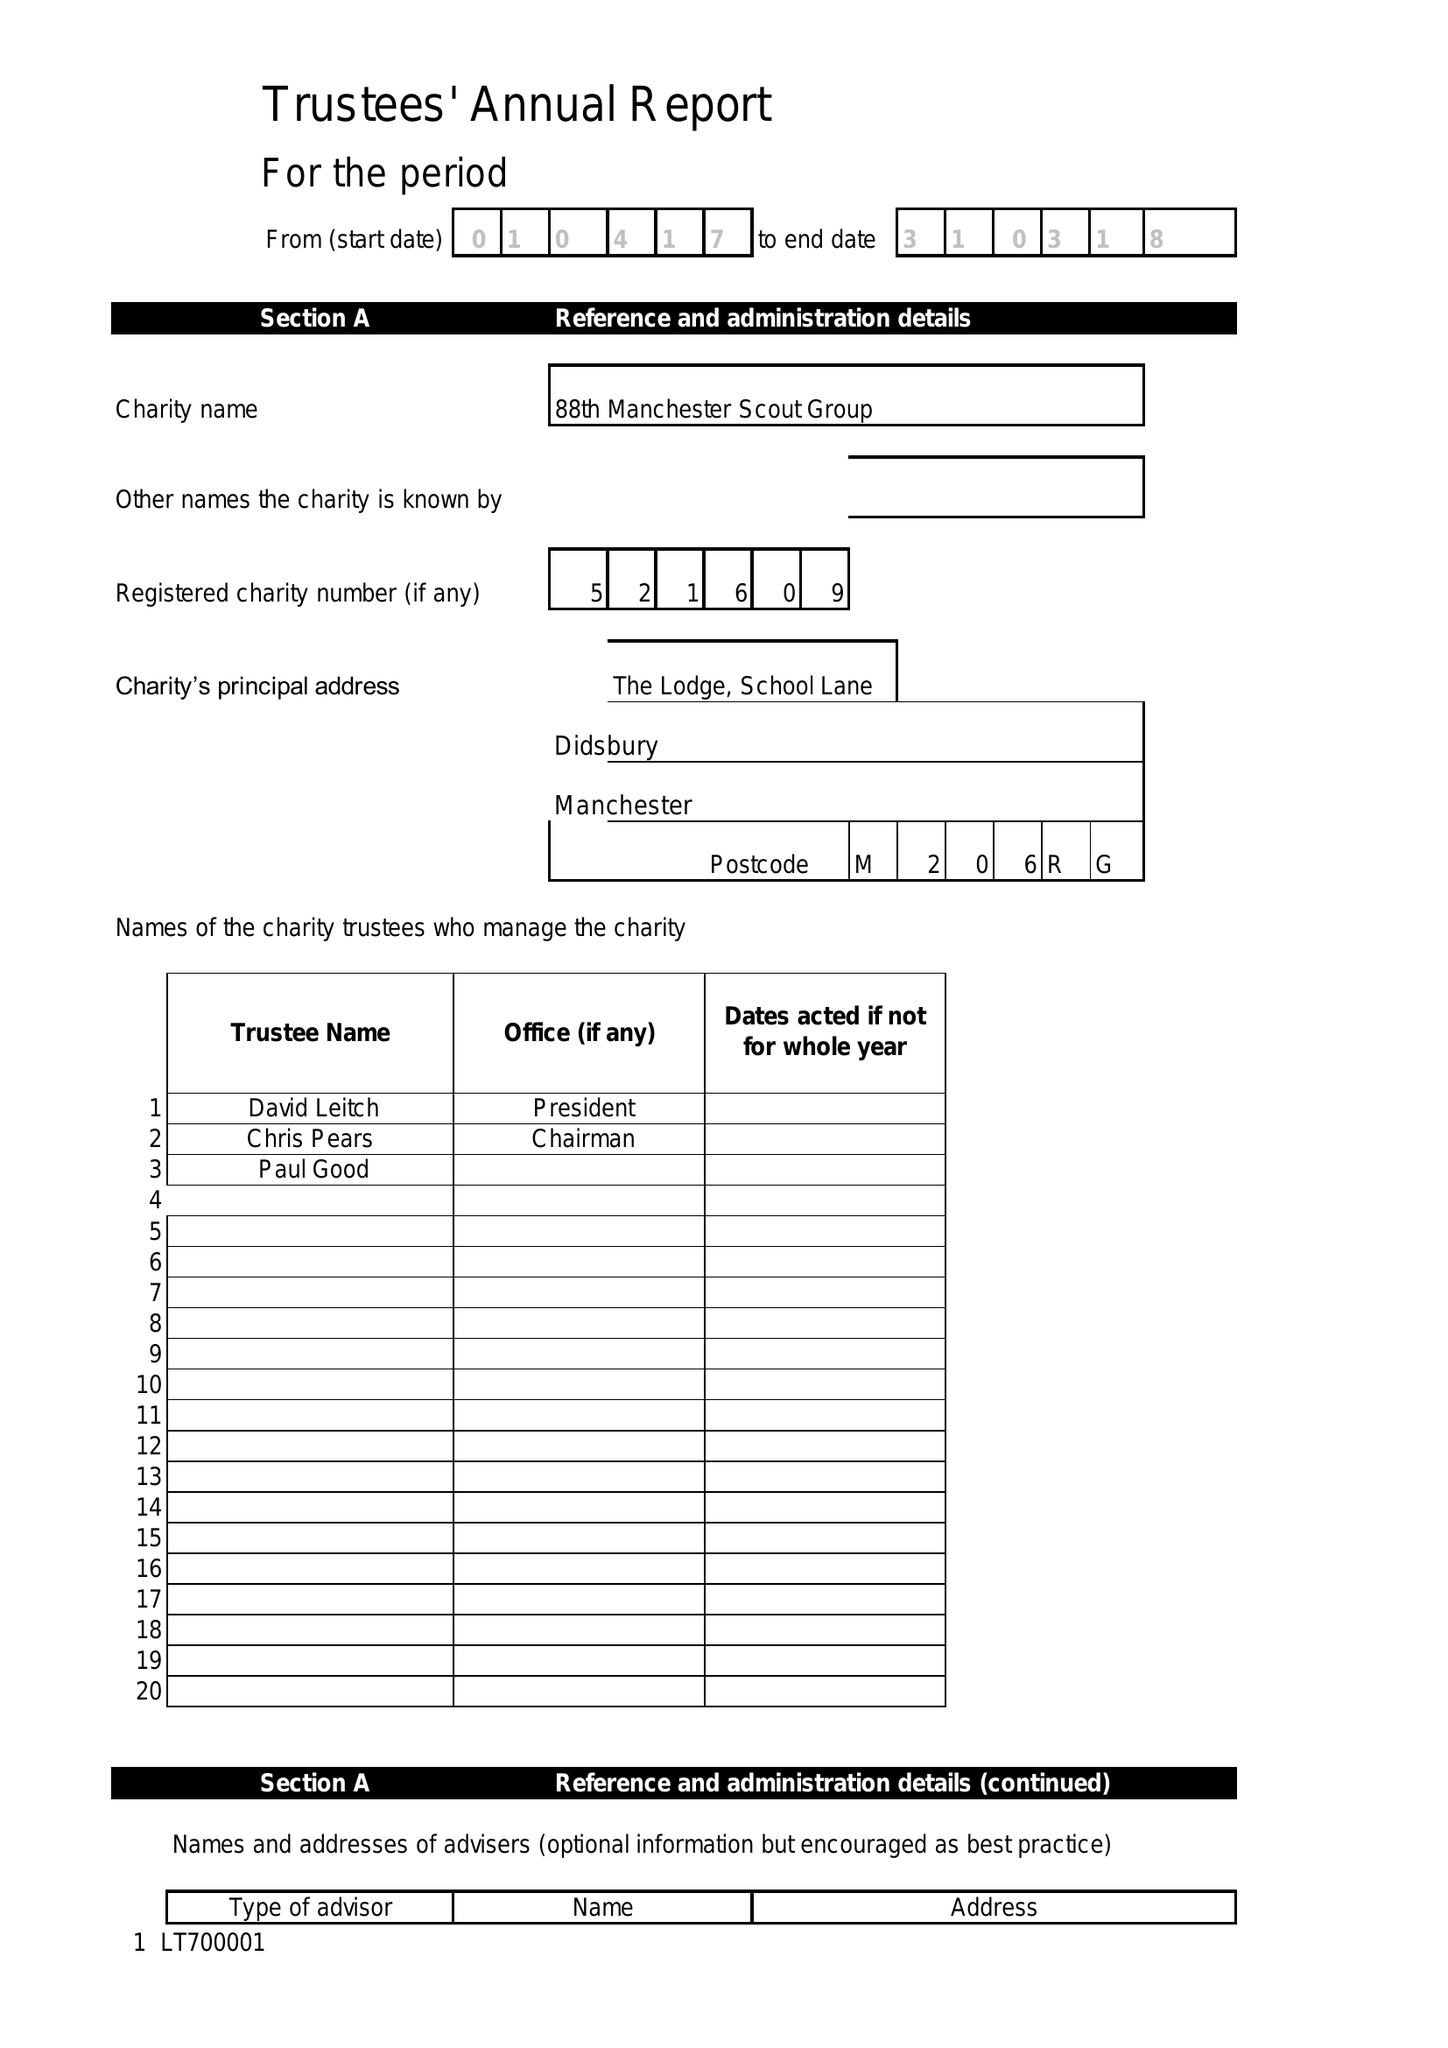What is the value for the address__street_line?
Answer the question using a single word or phrase. 11 GLADSTONE GROVE 